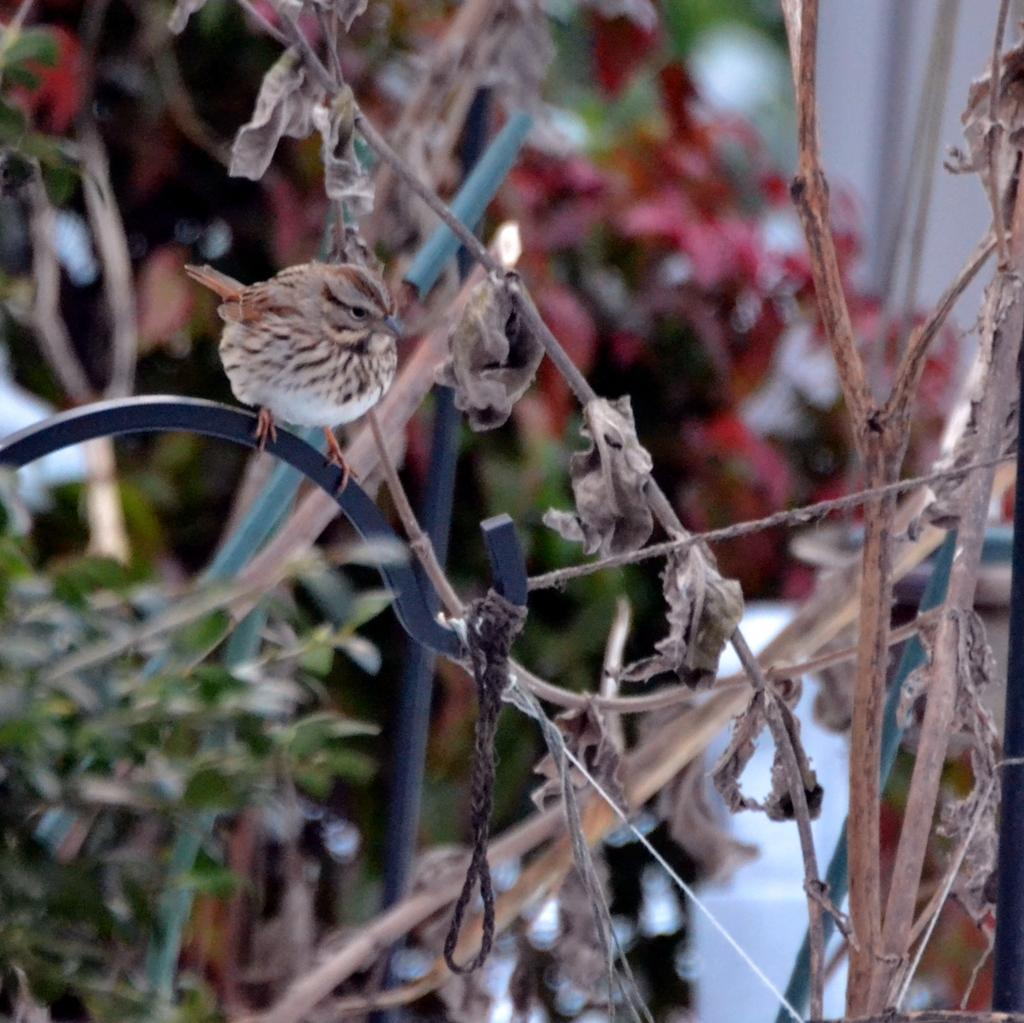What type of animal can be seen in the image? There is a bird in the image. What is the bird doing in the image? The bird is sitting on an object. What can be seen in the background of the image? There are trees in the background of the image. How would you describe the background of the image? The background of the image is blurred. What type of shame can be seen on the bird's face in the image? There is no indication of shame on the bird's face in the image, as birds do not experience emotions like shame. 